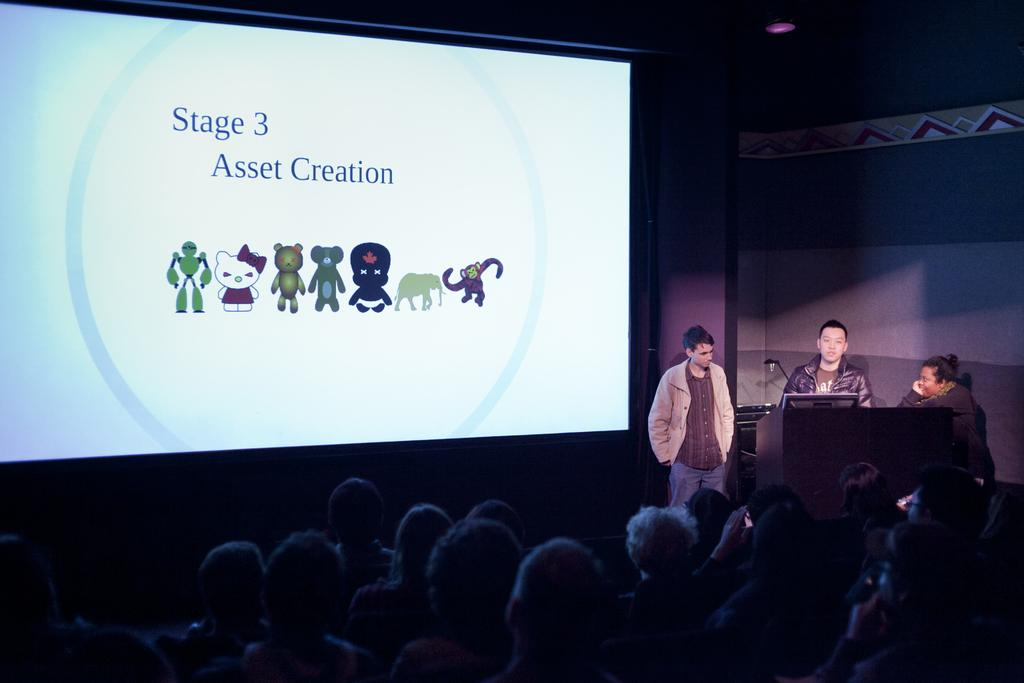How many people are standing near the podium in the image? There are three people standing near the podium in the image. What can be seen on the left side of the image? There is a screen on the left side of the image. Can you describe the people visible at the bottom of the image? There are people visible at the bottom of the image, but their specific features cannot be discerned from the provided facts. What type of wind can be seen blowing through the suit in the image? There is no suit or wind present in the image. Where is the drawer located in the image? There is no drawer present in the image. 